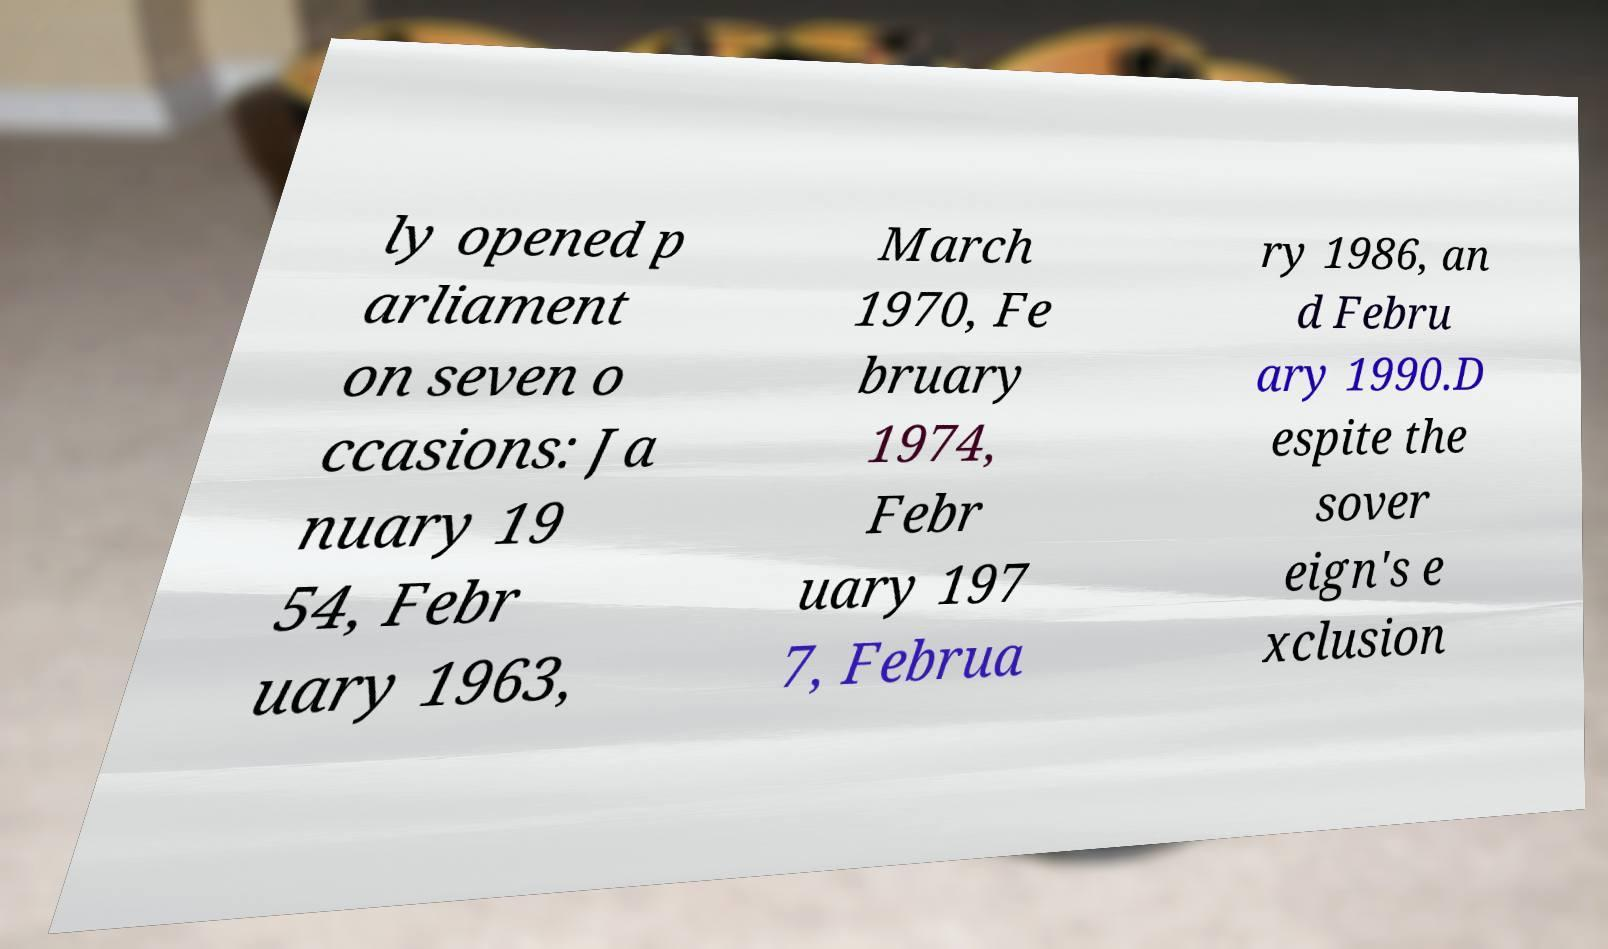I need the written content from this picture converted into text. Can you do that? ly opened p arliament on seven o ccasions: Ja nuary 19 54, Febr uary 1963, March 1970, Fe bruary 1974, Febr uary 197 7, Februa ry 1986, an d Febru ary 1990.D espite the sover eign's e xclusion 